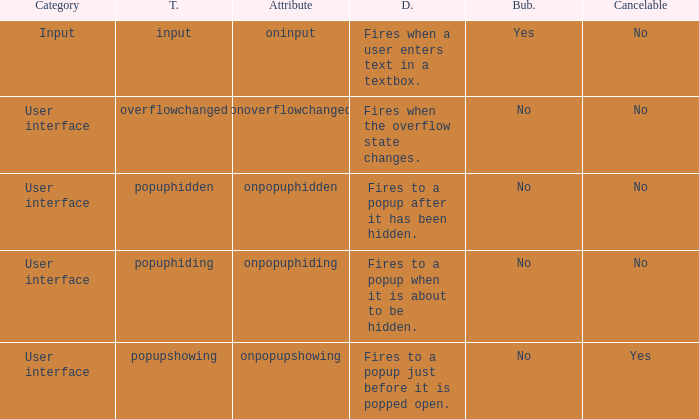What's the cancelable with bubbles being yes No. 